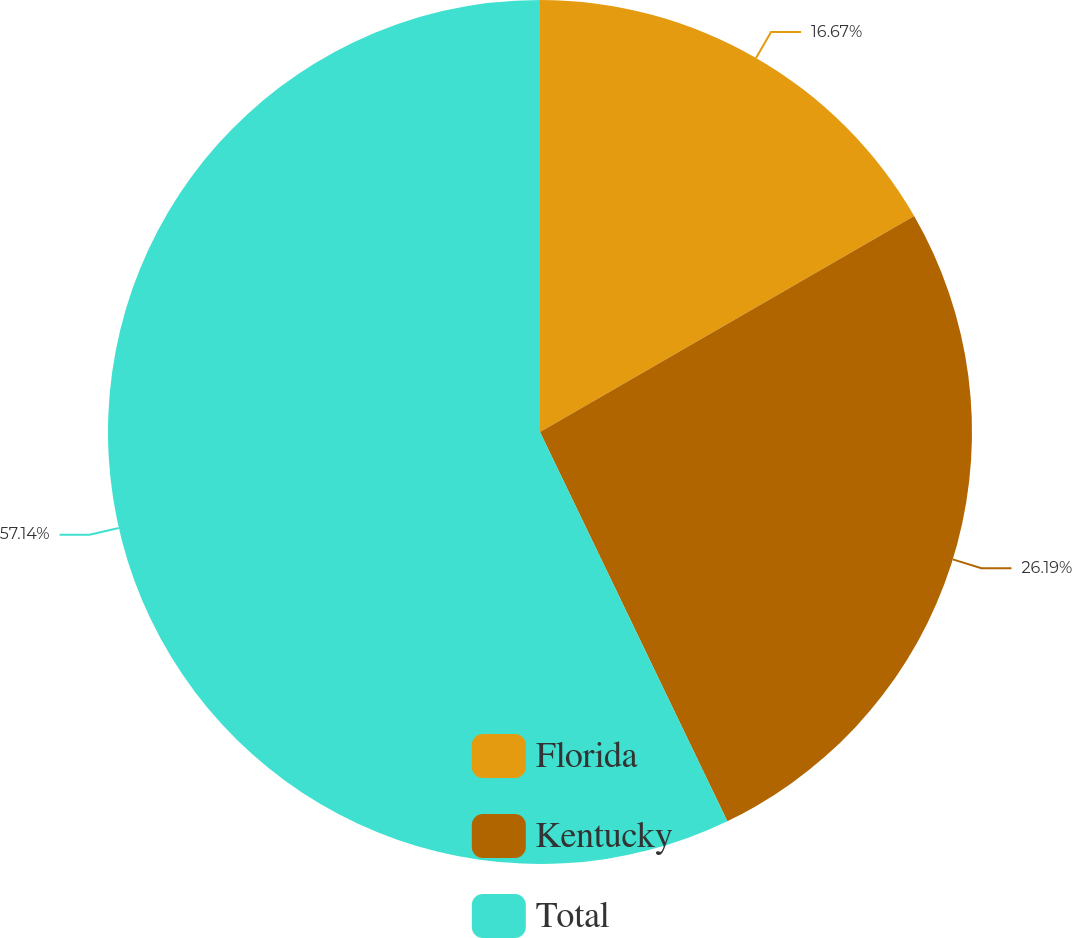Convert chart. <chart><loc_0><loc_0><loc_500><loc_500><pie_chart><fcel>Florida<fcel>Kentucky<fcel>Total<nl><fcel>16.67%<fcel>26.19%<fcel>57.14%<nl></chart> 